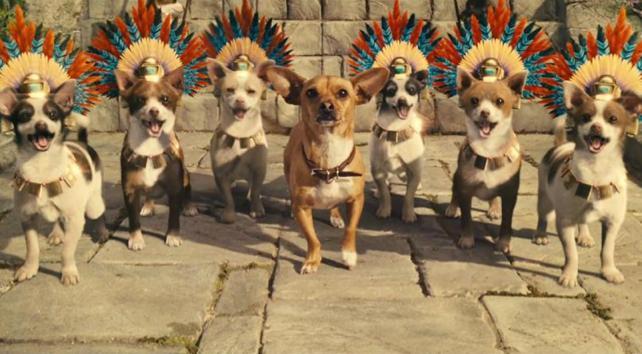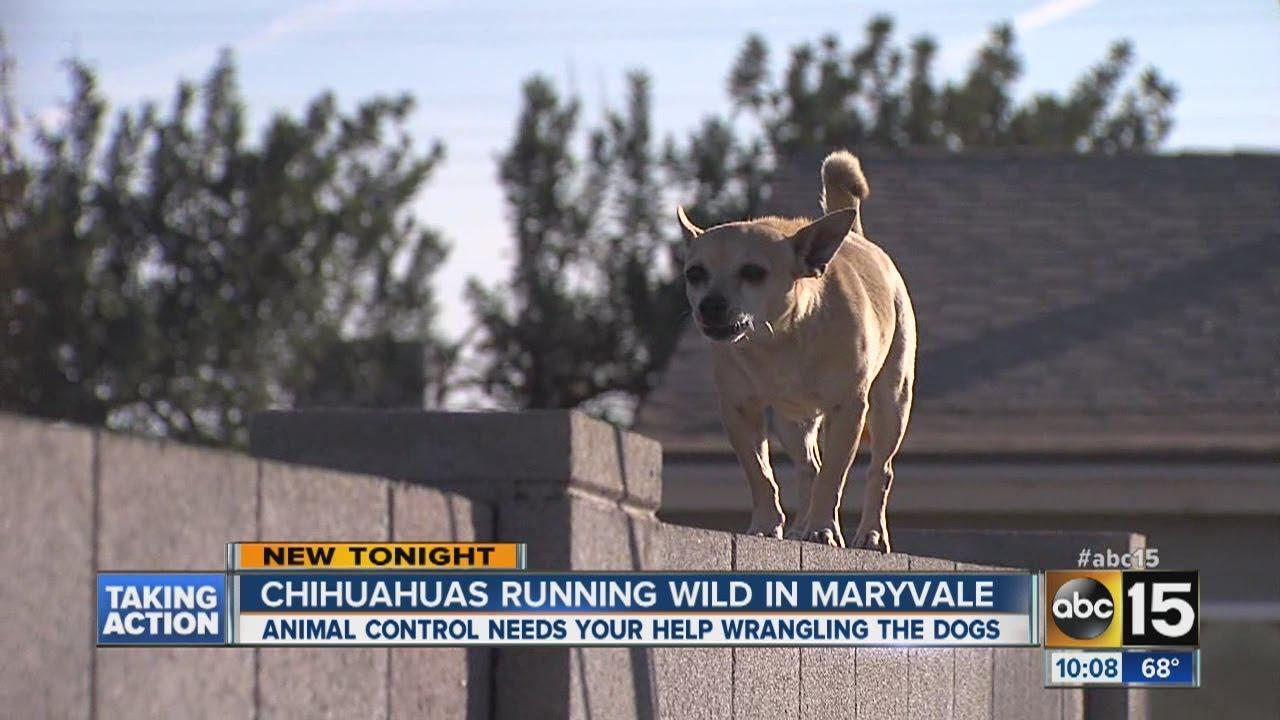The first image is the image on the left, the second image is the image on the right. Given the left and right images, does the statement "There is no more than one chihuahua in the right image." hold true? Answer yes or no. Yes. The first image is the image on the left, the second image is the image on the right. Assess this claim about the two images: "An image shows one dog, which is in a grassy area.". Correct or not? Answer yes or no. No. 